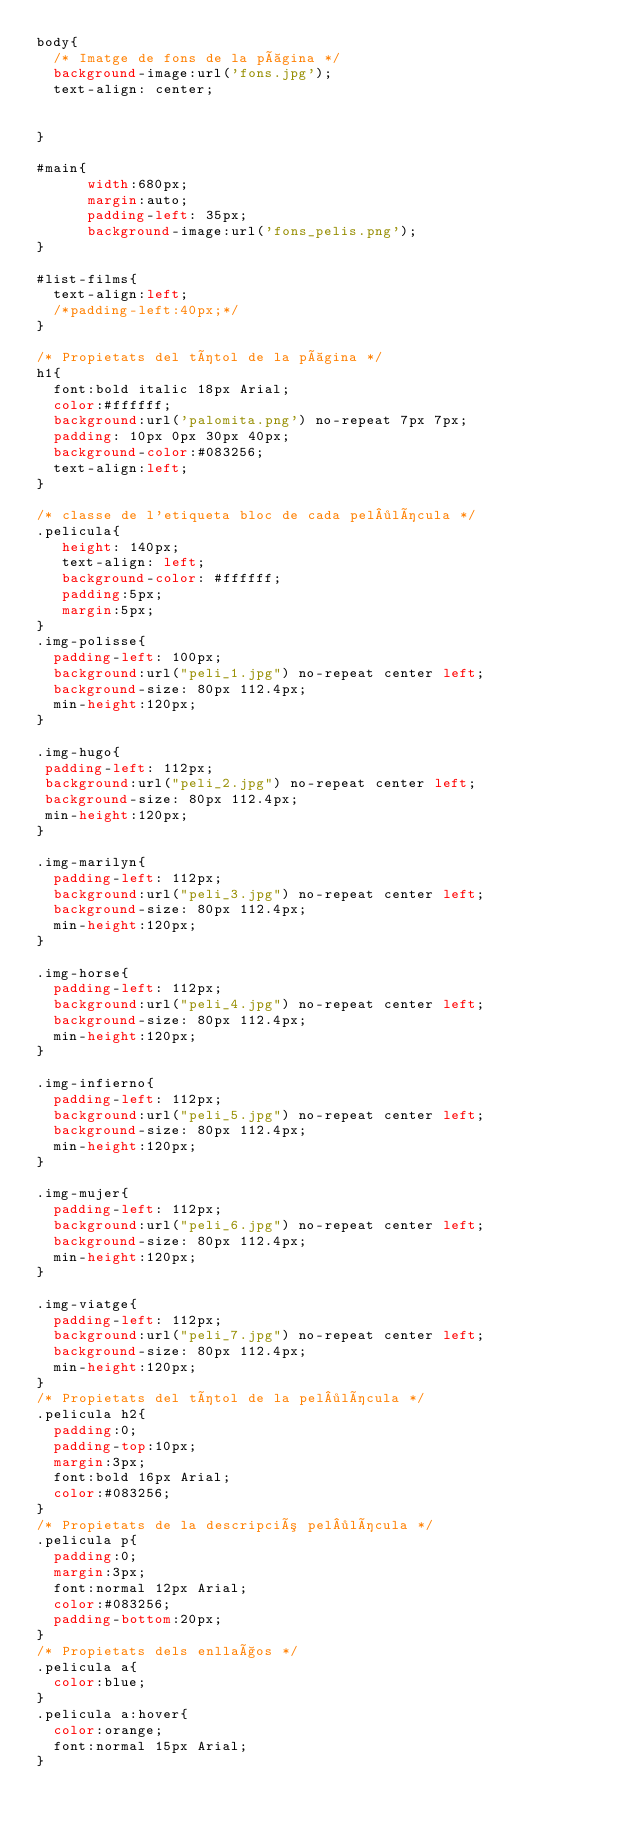<code> <loc_0><loc_0><loc_500><loc_500><_CSS_>body{
	/* Imatge de fons de la pàgina */
	background-image:url('fons.jpg');
	text-align: center;


}

#main{
			width:680px;
			margin:auto;
			padding-left: 35px;
			background-image:url('fons_pelis.png');
}

#list-films{
	text-align:left;
	/*padding-left:40px;*/
}

/* Propietats del títol de la pàgina */
h1{
	font:bold italic 18px Arial;
	color:#ffffff;
	background:url('palomita.png') no-repeat 7px 7px;
	padding: 10px 0px 30px 40px;
	background-color:#083256;
	text-align:left;
}

/* classe de l'etiqueta bloc de cada pel·lícula */
.pelicula{
	 height: 140px;
	 text-align: left;
	 background-color: #ffffff;
	 padding:5px;
	 margin:5px;
}
.img-polisse{
	padding-left: 100px;
	background:url("peli_1.jpg") no-repeat center left;
	background-size: 80px 112.4px;
	min-height:120px;
}

.img-hugo{
 padding-left: 112px;
 background:url("peli_2.jpg") no-repeat center left;
 background-size: 80px 112.4px;
 min-height:120px;
}

.img-marilyn{
	padding-left: 112px;
	background:url("peli_3.jpg") no-repeat center left;
	background-size: 80px 112.4px;
	min-height:120px;
}

.img-horse{
	padding-left: 112px;
	background:url("peli_4.jpg") no-repeat center left;
	background-size: 80px 112.4px;
	min-height:120px;
}

.img-infierno{
	padding-left: 112px;
	background:url("peli_5.jpg") no-repeat center left;
	background-size: 80px 112.4px;
	min-height:120px;
}

.img-mujer{
	padding-left: 112px;
	background:url("peli_6.jpg") no-repeat center left;
	background-size: 80px 112.4px;
	min-height:120px;
}

.img-viatge{
	padding-left: 112px;
	background:url("peli_7.jpg") no-repeat center left;
	background-size: 80px 112.4px;
	min-height:120px;
}
/* Propietats del títol de la pel·lícula */
.pelicula h2{
	padding:0;
	padding-top:10px;
	margin:3px;
	font:bold 16px Arial;
	color:#083256;
}
/* Propietats de la descripció pel·lícula */
.pelicula p{
	padding:0;
	margin:3px;
	font:normal 12px Arial;
	color:#083256;
	padding-bottom:20px;
}
/* Propietats dels enllaços */
.pelicula a{
	color:blue;
}
.pelicula a:hover{
	color:orange;
	font:normal 15px Arial;
}</code> 